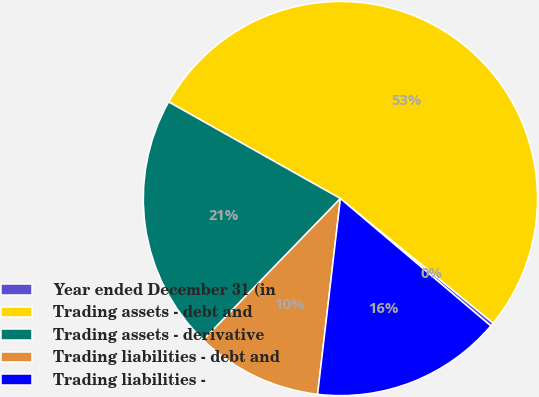Convert chart. <chart><loc_0><loc_0><loc_500><loc_500><pie_chart><fcel>Year ended December 31 (in<fcel>Trading assets - debt and<fcel>Trading assets - derivative<fcel>Trading liabilities - debt and<fcel>Trading liabilities -<nl><fcel>0.3%<fcel>52.73%<fcel>20.9%<fcel>10.41%<fcel>15.66%<nl></chart> 